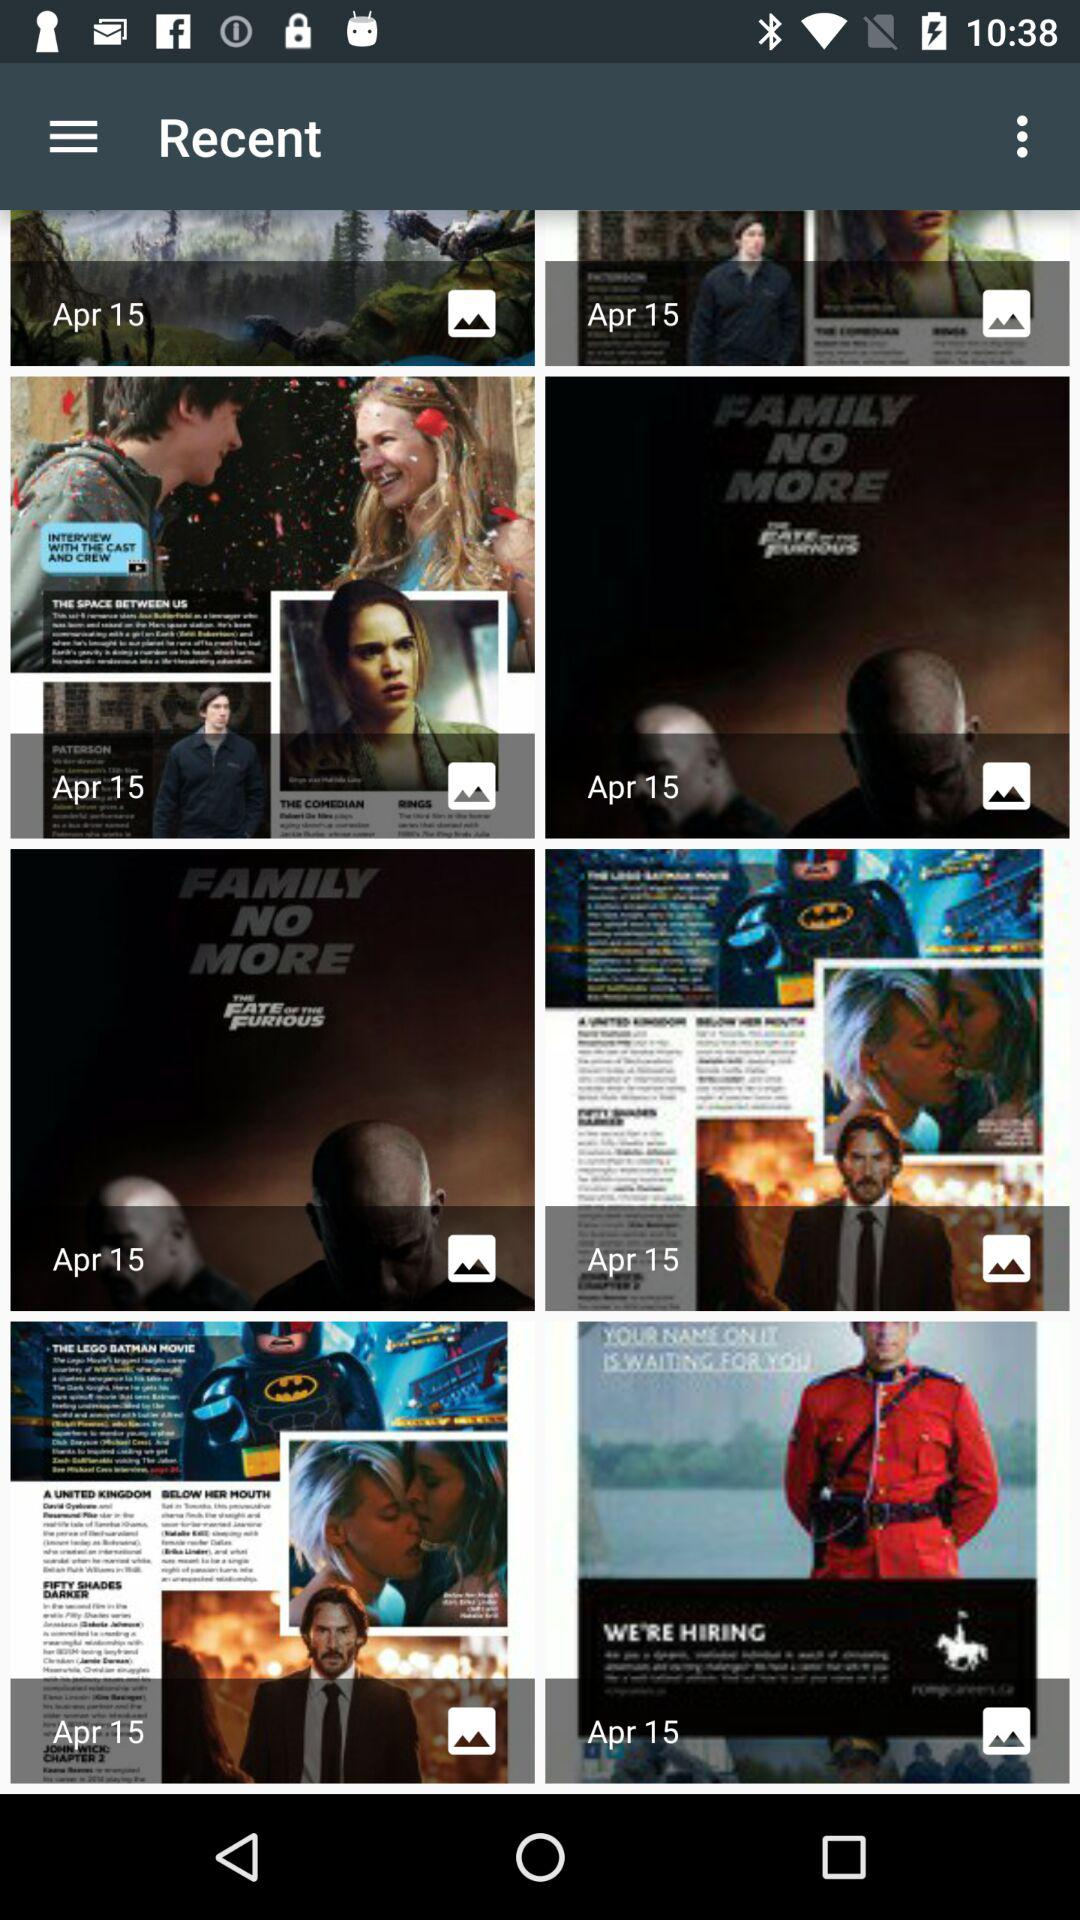What is the date? The date is April 15. 